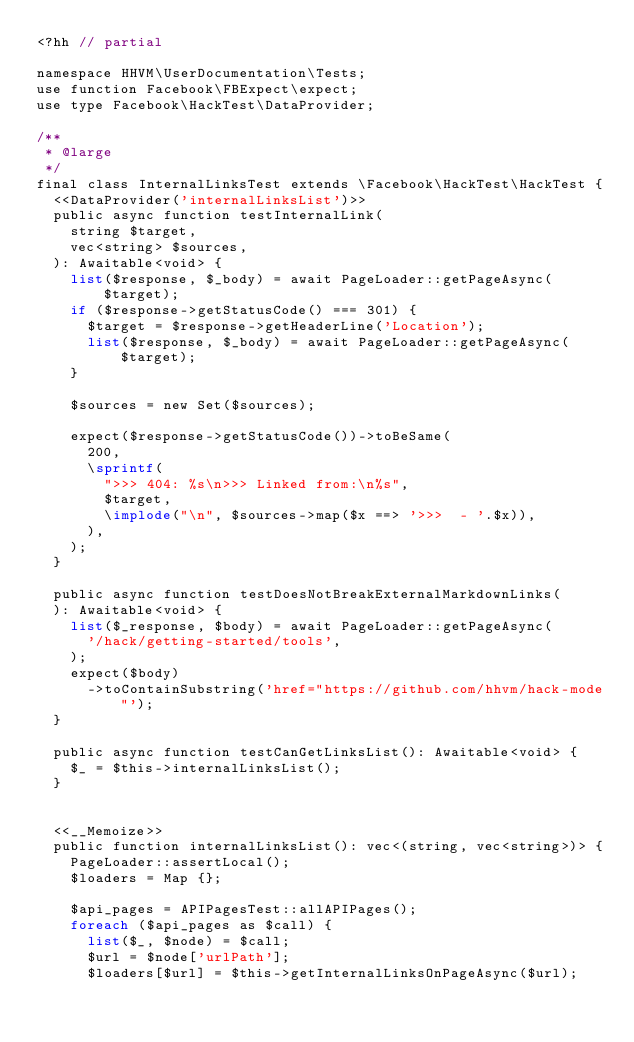Convert code to text. <code><loc_0><loc_0><loc_500><loc_500><_PHP_><?hh // partial

namespace HHVM\UserDocumentation\Tests;
use function Facebook\FBExpect\expect;
use type Facebook\HackTest\DataProvider;

/**
 * @large
 */
final class InternalLinksTest extends \Facebook\HackTest\HackTest {
  <<DataProvider('internalLinksList')>>
  public async function testInternalLink(
    string $target,
    vec<string> $sources,
  ): Awaitable<void> {
    list($response, $_body) = await PageLoader::getPageAsync($target);
    if ($response->getStatusCode() === 301) {
      $target = $response->getHeaderLine('Location');
      list($response, $_body) = await PageLoader::getPageAsync($target);
    }

    $sources = new Set($sources);

    expect($response->getStatusCode())->toBeSame(
      200,
      \sprintf(
        ">>> 404: %s\n>>> Linked from:\n%s",
        $target,
        \implode("\n", $sources->map($x ==> '>>>  - '.$x)),
      ),
    );
  }

  public async function testDoesNotBreakExternalMarkdownLinks(
  ): Awaitable<void> {
    list($_response, $body) = await PageLoader::getPageAsync(
      '/hack/getting-started/tools',
    );
    expect($body)
      ->toContainSubstring('href="https://github.com/hhvm/hack-mode"');
  }

  public async function testCanGetLinksList(): Awaitable<void> {
    $_ = $this->internalLinksList();
  }


  <<__Memoize>>
  public function internalLinksList(): vec<(string, vec<string>)> {
    PageLoader::assertLocal();
    $loaders = Map {};

    $api_pages = APIPagesTest::allAPIPages();
    foreach ($api_pages as $call) {
      list($_, $node) = $call;
      $url = $node['urlPath'];
      $loaders[$url] = $this->getInternalLinksOnPageAsync($url);</code> 